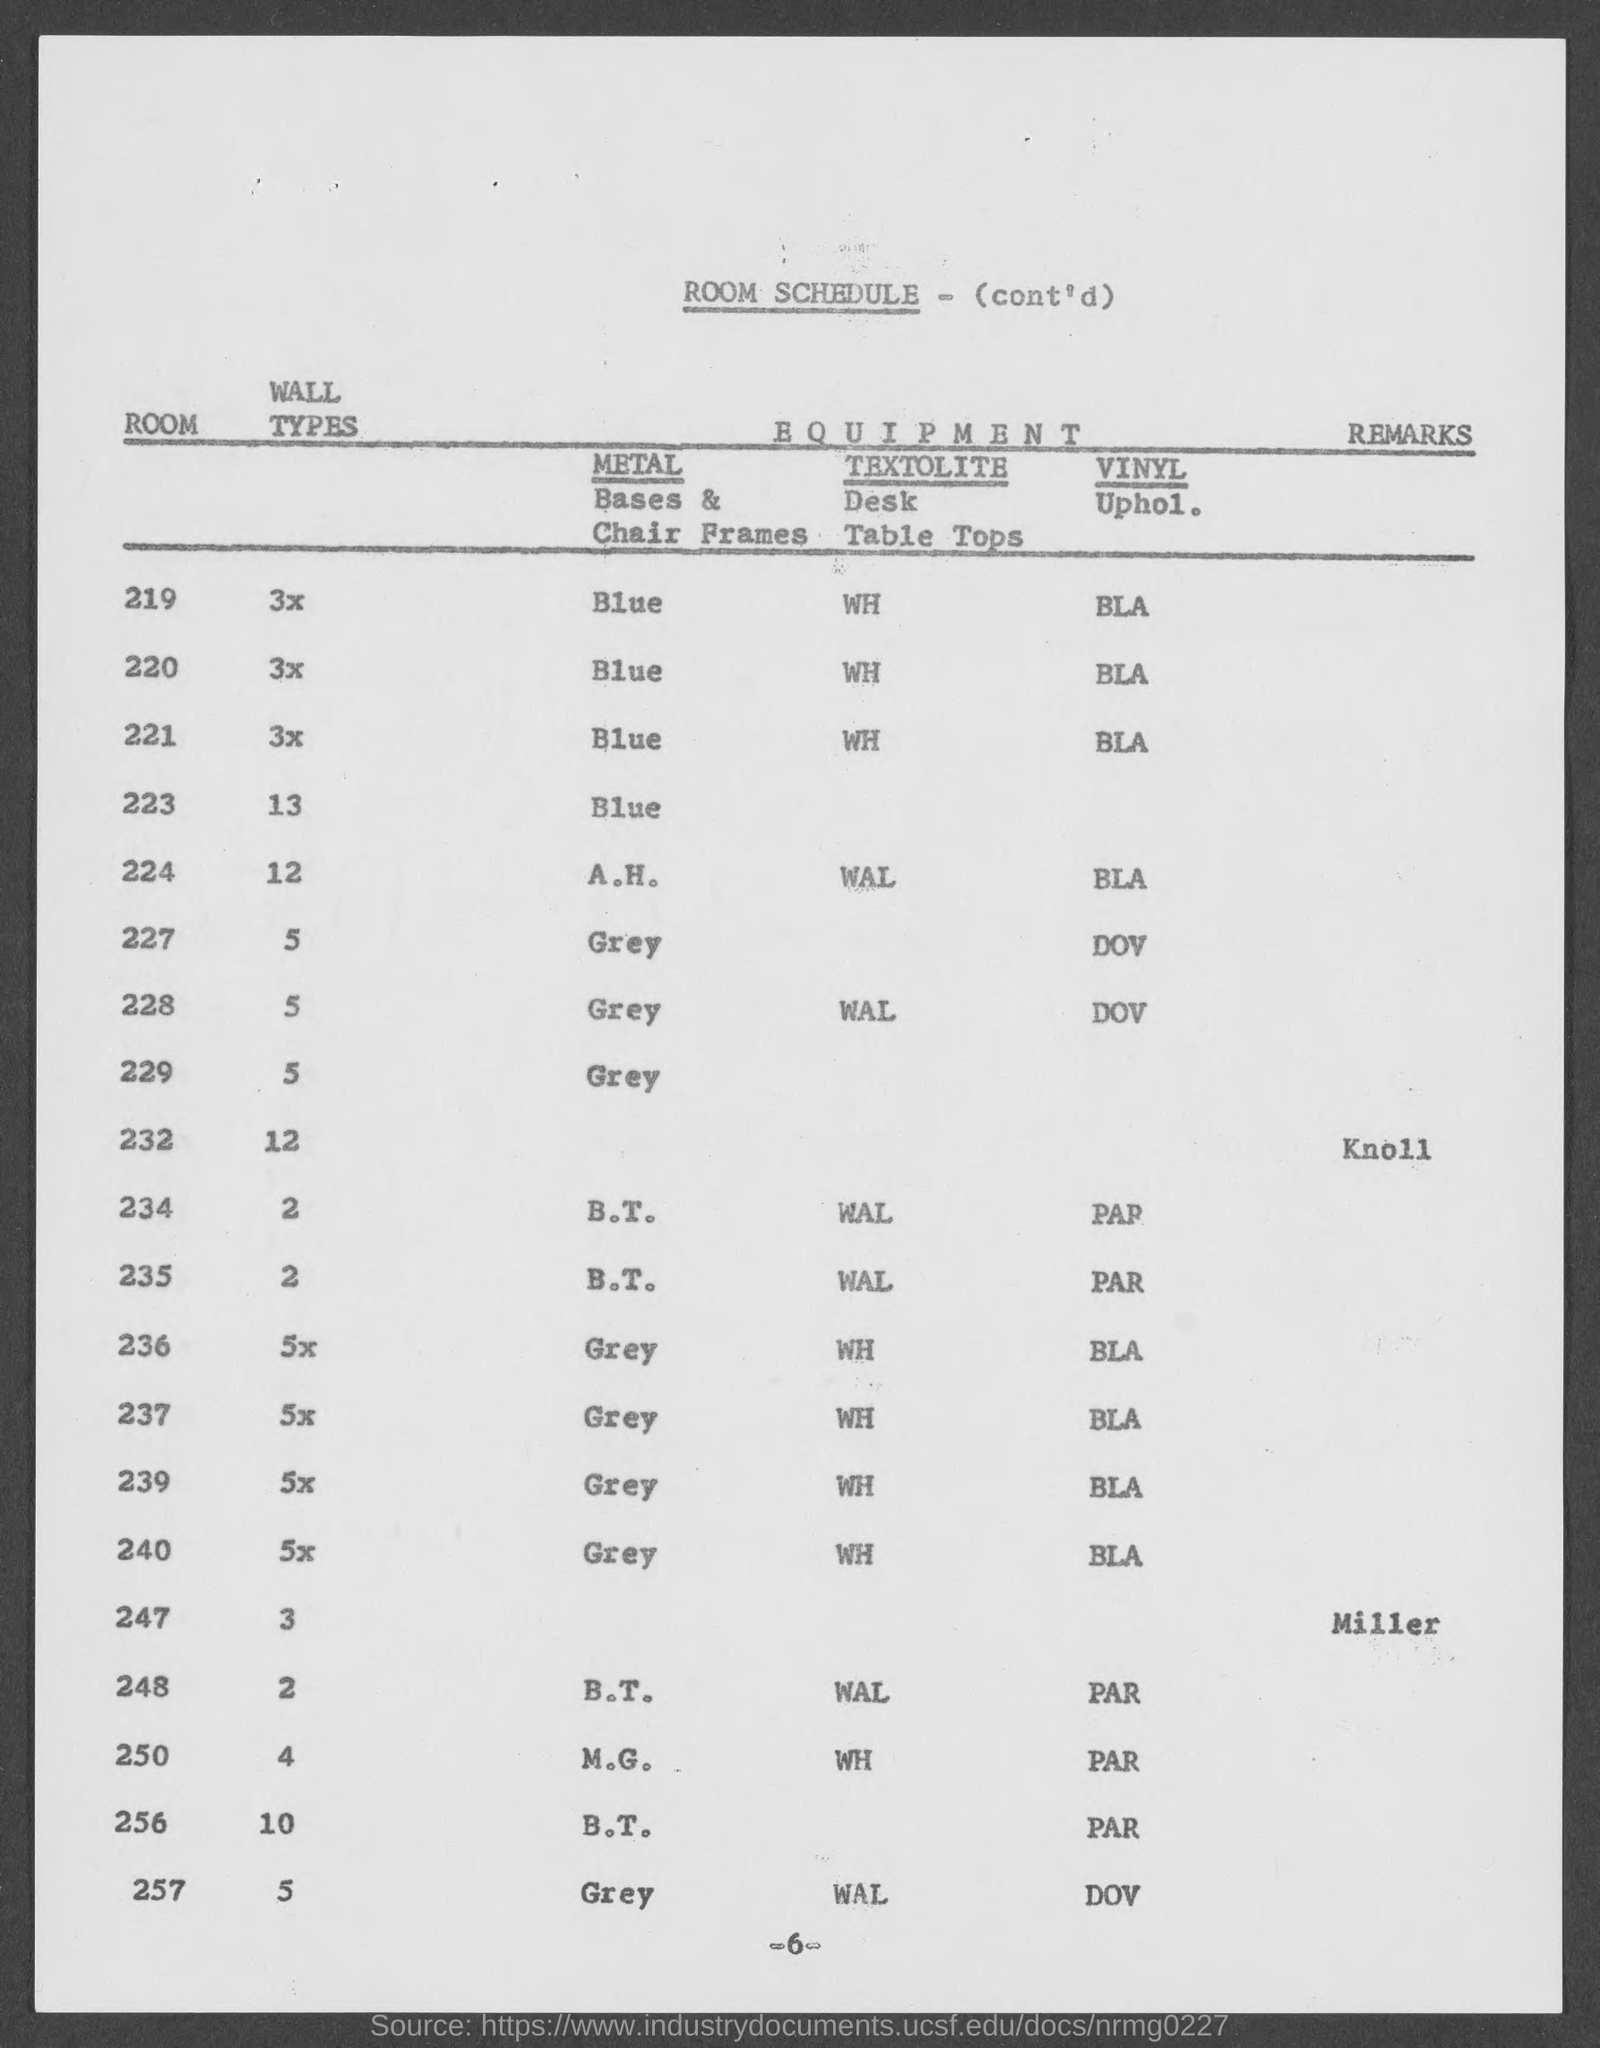Highlight a few significant elements in this photo. The title of the table is 'Room Schedule (Cont'd).'. 